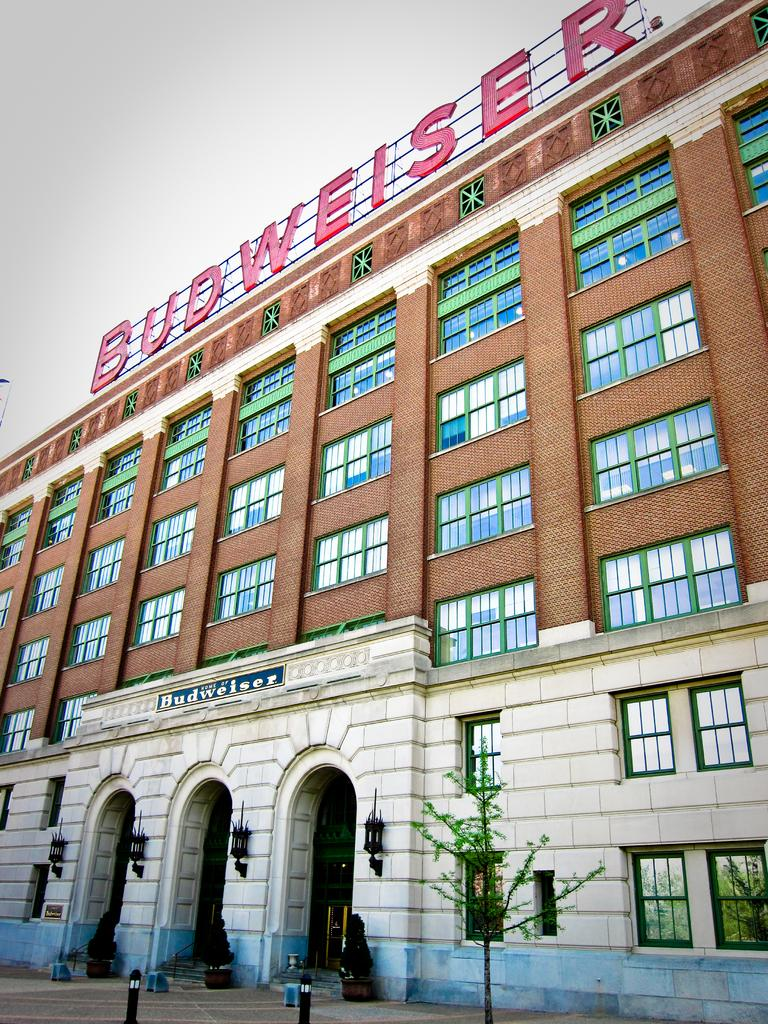What type of structure is present in the image? There is a building in the image. What features can be observed on the building? The building has windows and lamps, as well as name boards. Are there any other objects or elements in the image? Yes, there are poles, plants, and a tree in the image. What can be seen in the background of the image? The provided facts do not mention a specific type of school, or balls in the image. However, the sky is visible in the background of the image. How many balls are present in the image? There are no balls visible in the image. 